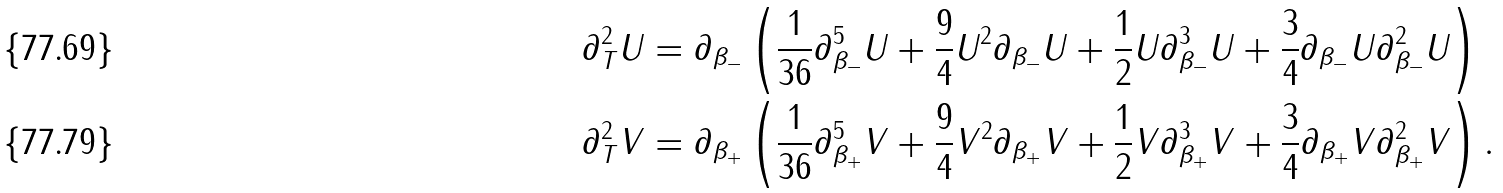Convert formula to latex. <formula><loc_0><loc_0><loc_500><loc_500>\partial _ { T } ^ { 2 } U & = \partial _ { \beta _ { - } } \left ( \frac { 1 } { 3 6 } \partial _ { \beta _ { - } } ^ { 5 } U + \frac { 9 } { 4 } U ^ { 2 } \partial _ { \beta _ { - } } U + \frac { 1 } { 2 } U \partial _ { \beta _ { - } } ^ { 3 } U + \frac { 3 } { 4 } \partial _ { \beta _ { - } } U \partial _ { \beta _ { - } } ^ { 2 } U \right ) \\ \partial _ { T } ^ { 2 } V & = \partial _ { \beta _ { + } } \left ( \frac { 1 } { 3 6 } \partial _ { \beta _ { + } } ^ { 5 } V + \frac { 9 } { 4 } V ^ { 2 } \partial _ { \beta _ { + } } V + \frac { 1 } { 2 } V \partial _ { \beta _ { + } } ^ { 3 } V + \frac { 3 } { 4 } \partial _ { \beta _ { + } } V \partial _ { \beta _ { + } } ^ { 2 } V \right ) .</formula> 